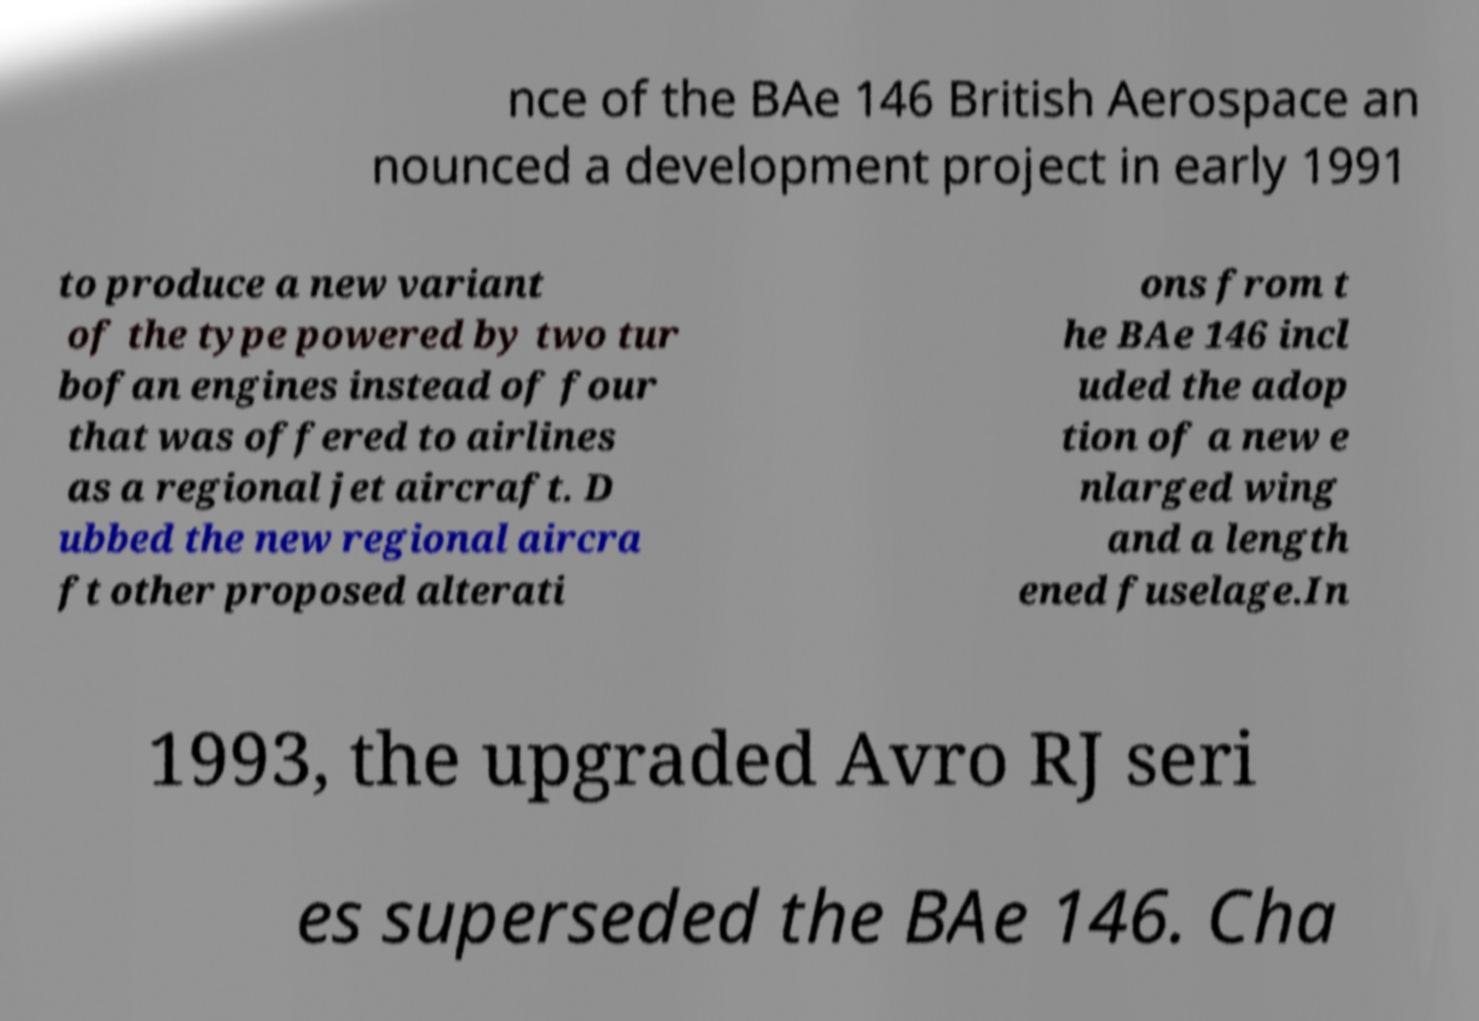Could you assist in decoding the text presented in this image and type it out clearly? nce of the BAe 146 British Aerospace an nounced a development project in early 1991 to produce a new variant of the type powered by two tur bofan engines instead of four that was offered to airlines as a regional jet aircraft. D ubbed the new regional aircra ft other proposed alterati ons from t he BAe 146 incl uded the adop tion of a new e nlarged wing and a length ened fuselage.In 1993, the upgraded Avro RJ seri es superseded the BAe 146. Cha 